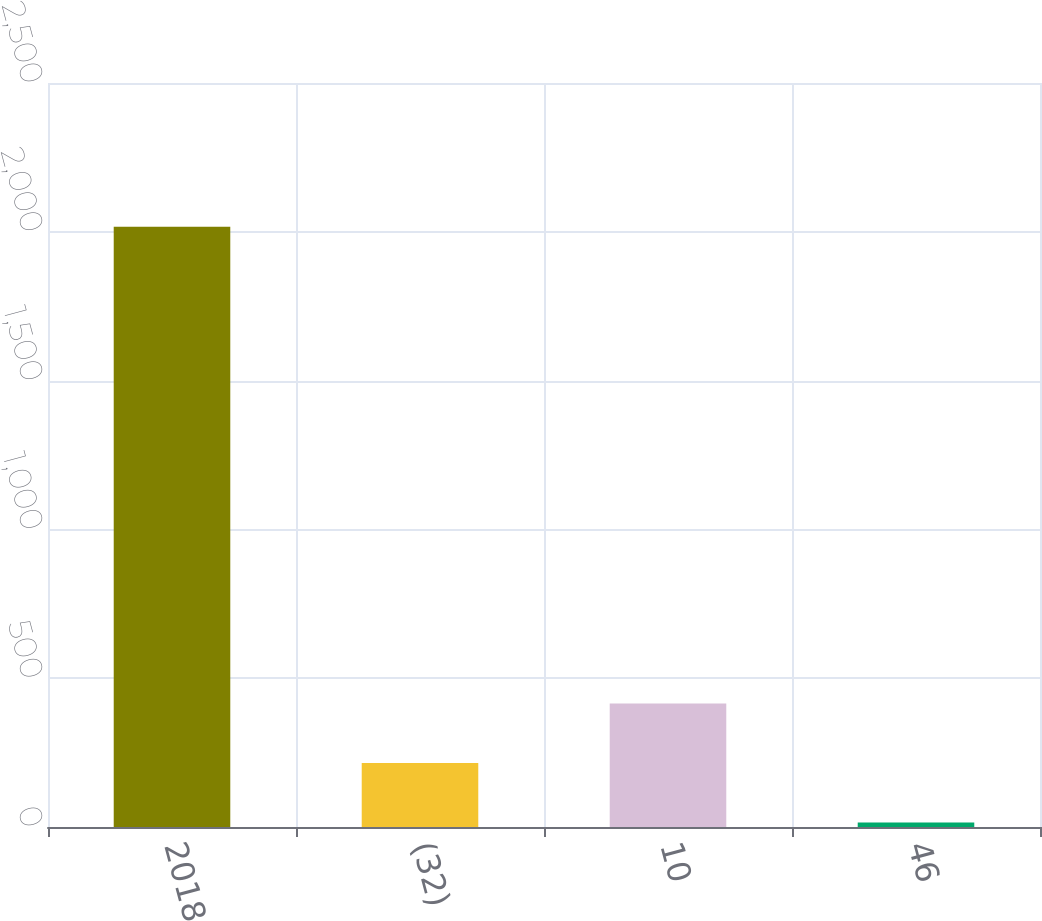Convert chart. <chart><loc_0><loc_0><loc_500><loc_500><bar_chart><fcel>2018<fcel>(32)<fcel>10<fcel>46<nl><fcel>2017<fcel>215.2<fcel>415.4<fcel>15<nl></chart> 